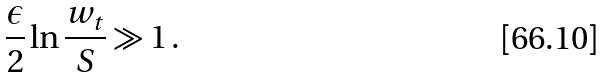<formula> <loc_0><loc_0><loc_500><loc_500>\frac { \epsilon } { 2 } \ln \frac { w _ { t } } S \gg 1 \, .</formula> 